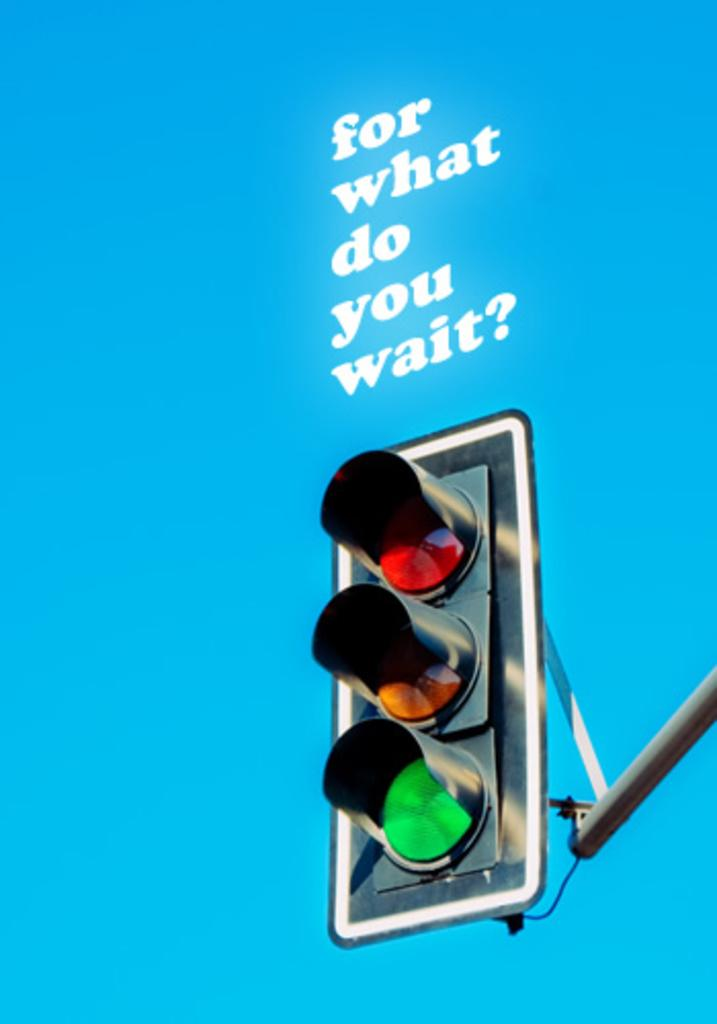Provide a one-sentence caption for the provided image. Traffic light with a saying on top that says "for what do you wait?". 